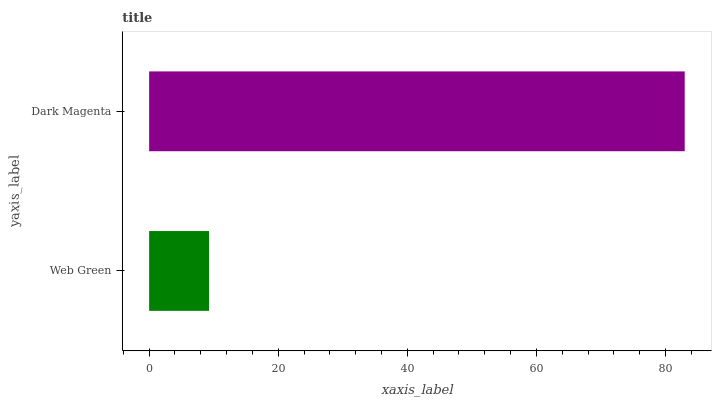Is Web Green the minimum?
Answer yes or no. Yes. Is Dark Magenta the maximum?
Answer yes or no. Yes. Is Dark Magenta the minimum?
Answer yes or no. No. Is Dark Magenta greater than Web Green?
Answer yes or no. Yes. Is Web Green less than Dark Magenta?
Answer yes or no. Yes. Is Web Green greater than Dark Magenta?
Answer yes or no. No. Is Dark Magenta less than Web Green?
Answer yes or no. No. Is Dark Magenta the high median?
Answer yes or no. Yes. Is Web Green the low median?
Answer yes or no. Yes. Is Web Green the high median?
Answer yes or no. No. Is Dark Magenta the low median?
Answer yes or no. No. 